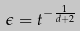Convert formula to latex. <formula><loc_0><loc_0><loc_500><loc_500>\epsilon = t ^ { - \frac { 1 } { d + 2 } }</formula> 